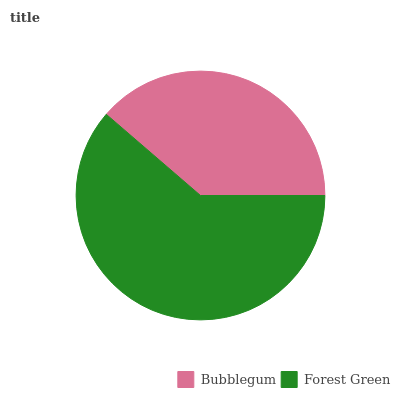Is Bubblegum the minimum?
Answer yes or no. Yes. Is Forest Green the maximum?
Answer yes or no. Yes. Is Forest Green the minimum?
Answer yes or no. No. Is Forest Green greater than Bubblegum?
Answer yes or no. Yes. Is Bubblegum less than Forest Green?
Answer yes or no. Yes. Is Bubblegum greater than Forest Green?
Answer yes or no. No. Is Forest Green less than Bubblegum?
Answer yes or no. No. Is Forest Green the high median?
Answer yes or no. Yes. Is Bubblegum the low median?
Answer yes or no. Yes. Is Bubblegum the high median?
Answer yes or no. No. Is Forest Green the low median?
Answer yes or no. No. 